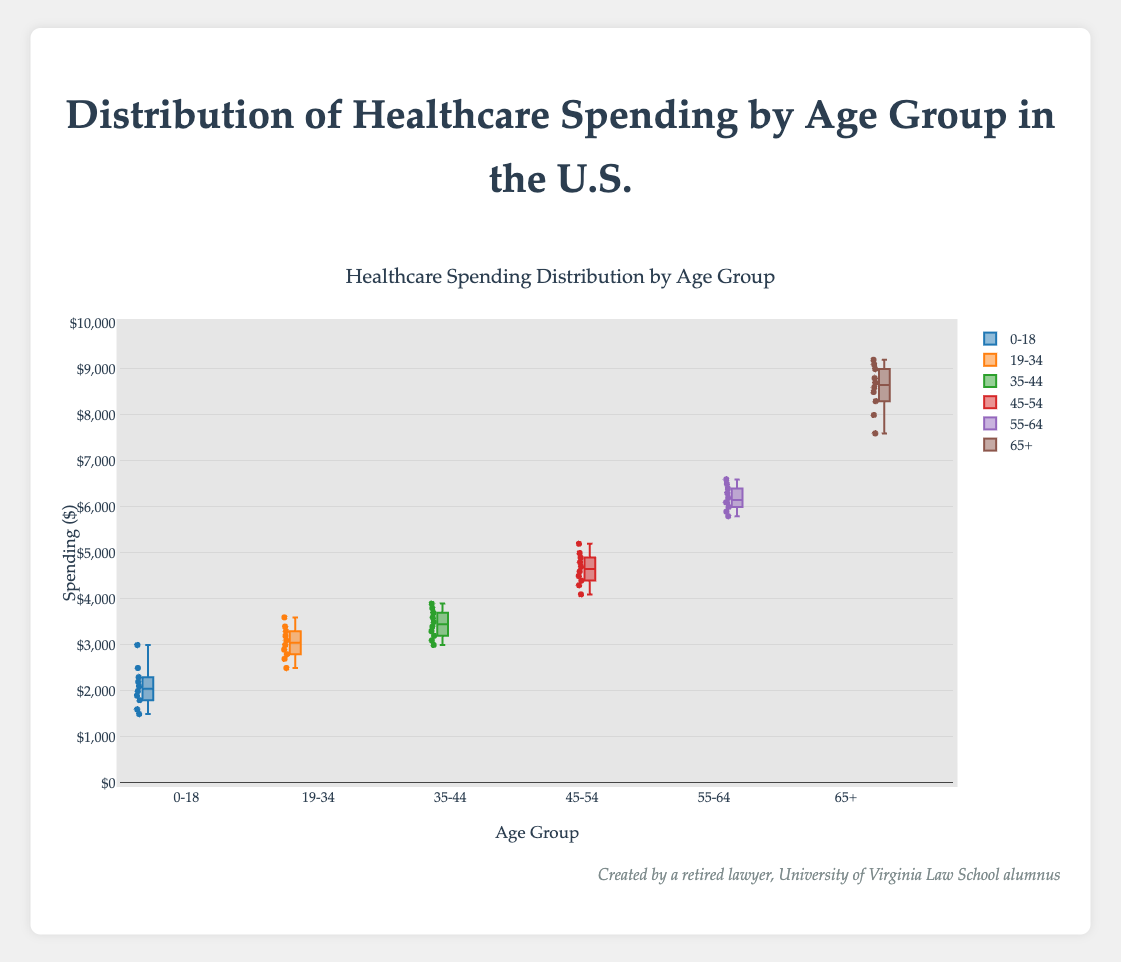What's the title of the figure? The title of the figure is usually displayed prominently at the top and conveys the overall subject of the data being presented. Here, the title is "Distribution of Healthcare Spending by Age Group in the U.S.".
Answer: Distribution of Healthcare Spending by Age Group in the U.S What are the age groups included in the box plot? The age groups are indicated along the x-axis, representing different categories. Here, the age groups are "0-18", "19-34", "35-44", "45-54", "55-64", and "65+".
Answer: 0-18, 19-34, 35-44, 45-54, 55-64, 65+ Which age group has the highest median healthcare spending? In a box plot, the median value is represented by the horizontal line inside the box. For the age group "65+", the median line is at the highest point compared to other age groups, indicating the highest median spending.
Answer: 65+ What is the range of healthcare spending for the age group "0-18"? The range is calculated by subtracting the lowest value (the bottom whisker) from the highest value (the top whisker). For "0-18", the lowest value is $1500 and the highest value is $3000.
Answer: $1500 In which age group is healthcare spending the most variable? Variability can be determined by looking at the length of the box and whiskers. For the age group "65+", the box and whiskers are the longest, indicating the highest variability.
Answer: 65+ Compare the medians of "19-34" and "35-44". Which age group has a higher median healthcare spending? The median is the line inside the box. Comparing the lines, "35-44" has a higher median than "19-34".
Answer: 35-44 What is the interquartile range (IQR) for the age group "45-54"? The IQR is found by subtracting the value at the bottom of the box (Q1) from the value at the top of the box (Q3). For "45-54", Q1 is approximately $4400 and Q3 is approximately $4900.
Answer: $500 Is the median healthcare spending for the age group "55-64" above or below $6000? The median line inside the box for the age group "55-64" is just above the $6000 mark.
Answer: Above For the age group "35-44", how many data points are within the box? The box plot includes all data points that fall between the first quartile (Q1) and the third quartile (Q3). For "35-44", since there are 10 data points and assuming a normal distribution, roughly half (5) should be within the box.
Answer: 5 Which age group's healthcare spending shows an outlier if any? Outliers in a box plot are often shown as points beyond the whiskers. The age group "0-18" has no data points beyond the whiskers, hence no outliers.
Answer: None 